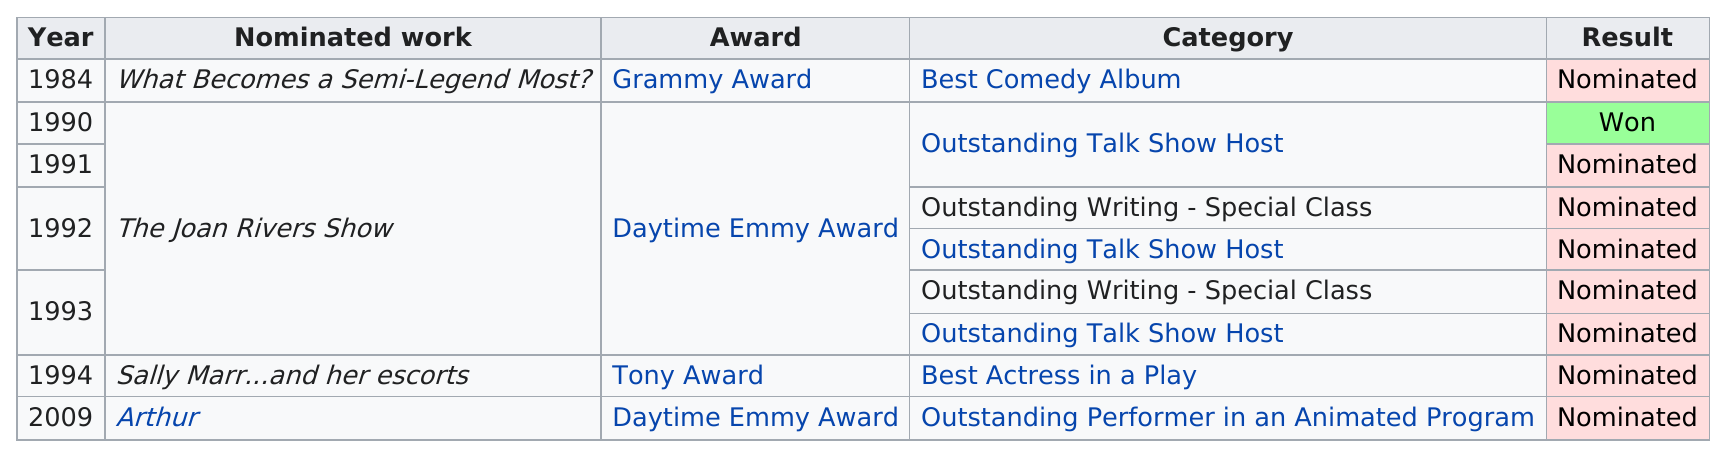Draw attention to some important aspects in this diagram. In the year 1994, Joan Rivers was nominated for a Tony Award for her work in the play "Sally Marr...and her escorts...". Joan Rivers has been most nominated for the Outstanding Talk Show Host award. Joan Rivers won a Daytime Emmy Award in the year 1990. 